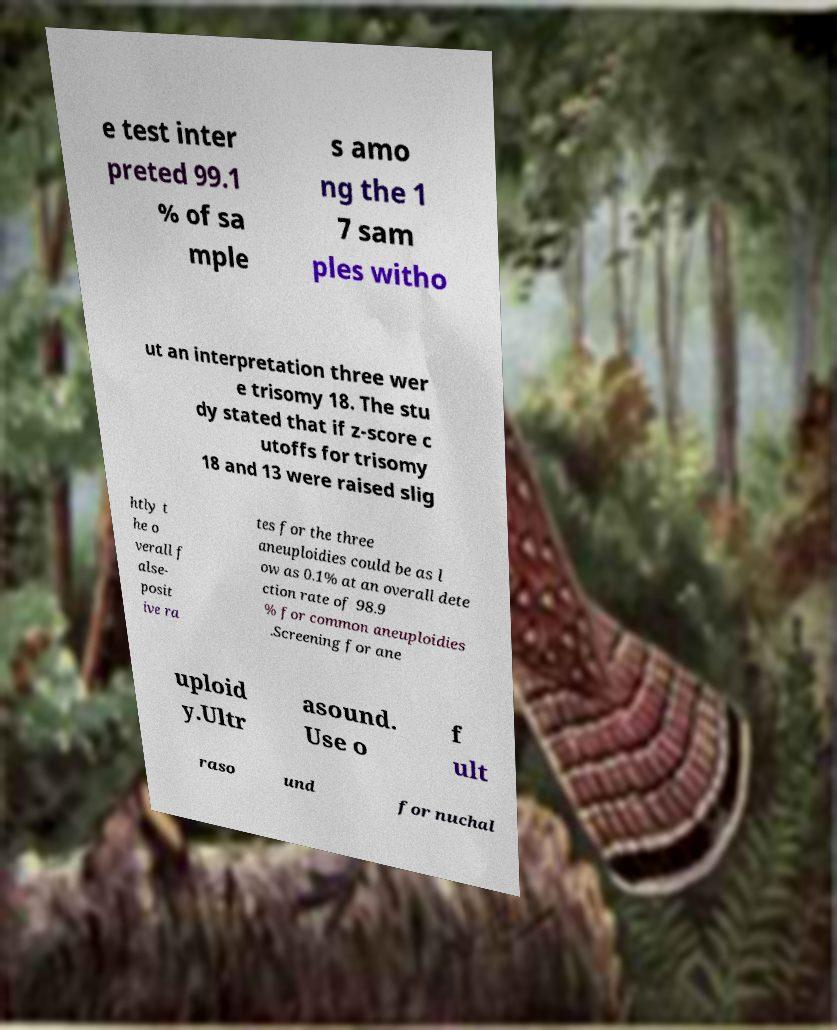Can you read and provide the text displayed in the image?This photo seems to have some interesting text. Can you extract and type it out for me? e test inter preted 99.1 % of sa mple s amo ng the 1 7 sam ples witho ut an interpretation three wer e trisomy 18. The stu dy stated that if z-score c utoffs for trisomy 18 and 13 were raised slig htly t he o verall f alse- posit ive ra tes for the three aneuploidies could be as l ow as 0.1% at an overall dete ction rate of 98.9 % for common aneuploidies .Screening for ane uploid y.Ultr asound. Use o f ult raso und for nuchal 